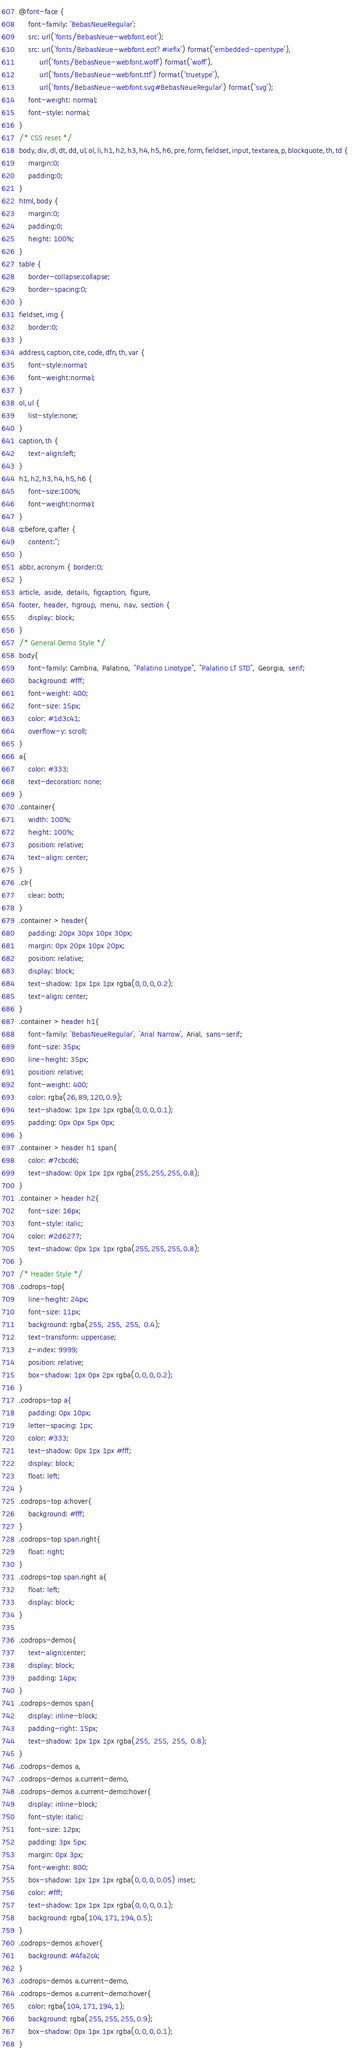<code> <loc_0><loc_0><loc_500><loc_500><_CSS_>@font-face {
    font-family: 'BebasNeueRegular';
    src: url('fonts/BebasNeue-webfont.eot');
    src: url('fonts/BebasNeue-webfont.eot?#iefix') format('embedded-opentype'),
         url('fonts/BebasNeue-webfont.woff') format('woff'),
         url('fonts/BebasNeue-webfont.ttf') format('truetype'),
         url('fonts/BebasNeue-webfont.svg#BebasNeueRegular') format('svg');
    font-weight: normal;
    font-style: normal;
}
/* CSS reset */
body,div,dl,dt,dd,ul,ol,li,h1,h2,h3,h4,h5,h6,pre,form,fieldset,input,textarea,p,blockquote,th,td { 
	margin:0;
	padding:0;
}
html,body {
	margin:0;
	padding:0;
	height: 100%;
}
table {
	border-collapse:collapse;
	border-spacing:0;
}
fieldset,img { 
	border:0;
}
address,caption,cite,code,dfn,th,var {
	font-style:normal;
	font-weight:normal;
}
ol,ul {
	list-style:none;
}
caption,th {
	text-align:left;
}
h1,h2,h3,h4,h5,h6 {
	font-size:100%;
	font-weight:normal;
}
q:before,q:after {
	content:'';
}
abbr,acronym { border:0;
}
article, aside, details, figcaption, figure,
footer, header, hgroup, menu, nav, section {
	display: block;
}
/* General Demo Style */
body{
	font-family: Cambria, Palatino, "Palatino Linotype", "Palatino LT STD", Georgia, serif;
	background: #fff;
	font-weight: 400;
	font-size: 15px;
	color: #1d3c41;
	overflow-y: scroll;
}
a{
	color: #333;
	text-decoration: none;
}
.container{
	width: 100%;
	height: 100%;
	position: relative;
	text-align: center;
}
.clr{
	clear: both;
}
.container > header{
	padding: 20px 30px 10px 30px;
	margin: 0px 20px 10px 20px;
	position: relative;
	display: block;
	text-shadow: 1px 1px 1px rgba(0,0,0,0.2);
    text-align: center;
}
.container > header h1{
	font-family: 'BebasNeueRegular', 'Arial Narrow', Arial, sans-serif;
	font-size: 35px;
	line-height: 35px;
	position: relative;
	font-weight: 400;
	color: rgba(26,89,120,0.9);
	text-shadow: 1px 1px 1px rgba(0,0,0,0.1);
    padding: 0px 0px 5px 0px;
}
.container > header h1 span{
	color: #7cbcd6;
	text-shadow: 0px 1px 1px rgba(255,255,255,0.8);
}
.container > header h2{
	font-size: 16px;
	font-style: italic;
	color: #2d6277;
	text-shadow: 0px 1px 1px rgba(255,255,255,0.8);
}
/* Header Style */
.codrops-top{
	line-height: 24px;
	font-size: 11px;
	background: rgba(255, 255, 255, 0.4);
	text-transform: uppercase;
	z-index: 9999;
	position: relative;
	box-shadow: 1px 0px 2px rgba(0,0,0,0.2);
}
.codrops-top a{
	padding: 0px 10px;
	letter-spacing: 1px;
	color: #333;
	text-shadow: 0px 1px 1px #fff;
	display: block;
	float: left;
}
.codrops-top a:hover{
	background: #fff;
}
.codrops-top span.right{
	float: right;
}
.codrops-top span.right a{
	float: left;
	display: block;
}

.codrops-demos{
	text-align:center;
	display: block;
	padding: 14px;
}
.codrops-demos span{
	display: inline-block;
	padding-right: 15px;
	text-shadow: 1px 1px 1px rgba(255, 255, 255, 0.8);
}
.codrops-demos a,
.codrops-demos a.current-demo,
.codrops-demos a.current-demo:hover{
    display: inline-block;
	font-style: italic;
	font-size: 12px;
	padding: 3px 5px;
	margin: 0px 3px;
	font-weight: 800;
	box-shadow: 1px 1px 1px rgba(0,0,0,0.05) inset;
	color: #fff;
	text-shadow: 1px 1px 1px rgba(0,0,0,0.1);
	background: rgba(104,171,194,0.5);
}
.codrops-demos a:hover{
	background: #4fa2c4;
}
.codrops-demos a.current-demo,
.codrops-demos a.current-demo:hover{
	color: rgba(104,171,194,1);
	background: rgba(255,255,255,0.9);
	box-shadow: 0px 1px 1px rgba(0,0,0,0.1);
}

</code> 